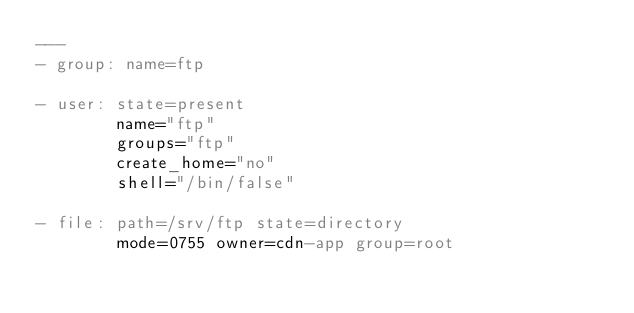Convert code to text. <code><loc_0><loc_0><loc_500><loc_500><_YAML_>---
- group: name=ftp

- user: state=present
        name="ftp"
        groups="ftp"
        create_home="no"
        shell="/bin/false"

- file: path=/srv/ftp state=directory
        mode=0755 owner=cdn-app group=root
</code> 